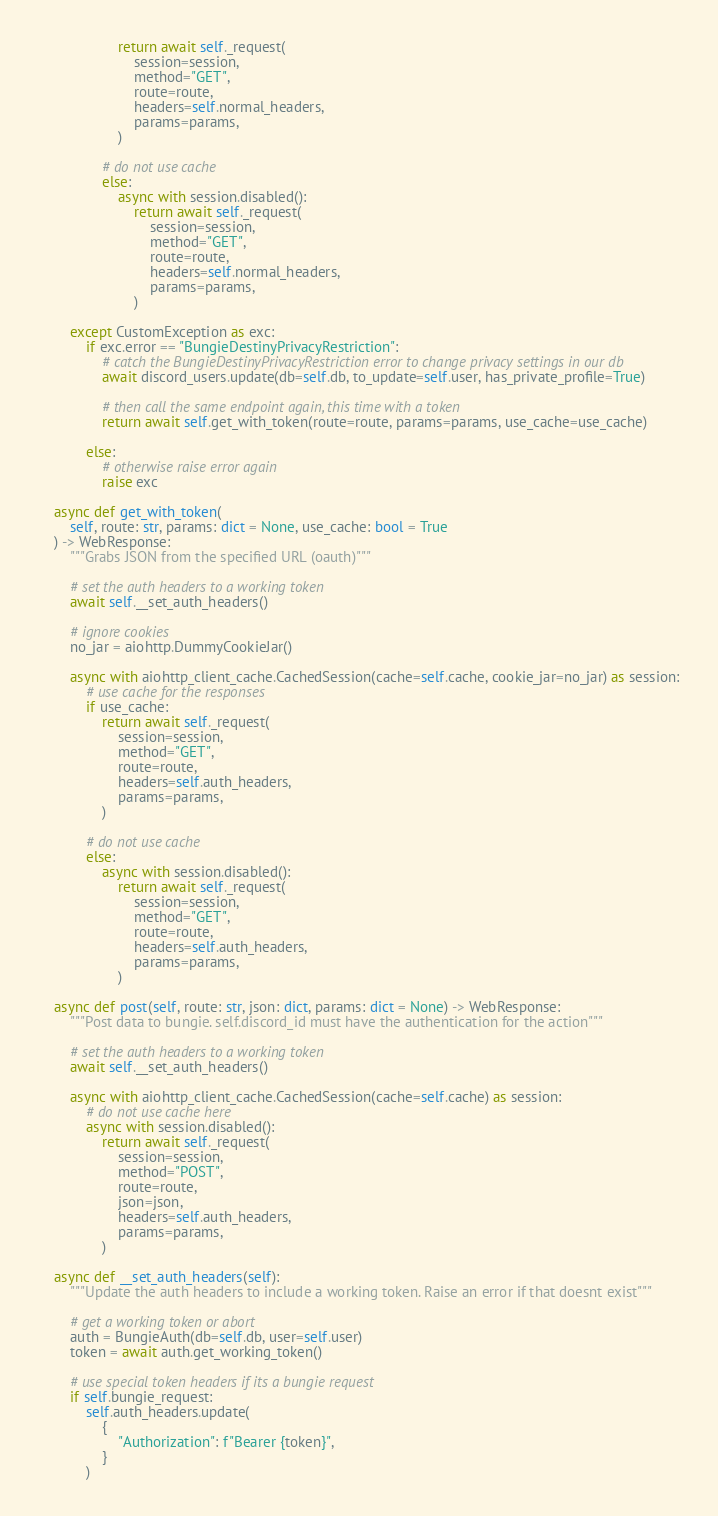<code> <loc_0><loc_0><loc_500><loc_500><_Python_>                    return await self._request(
                        session=session,
                        method="GET",
                        route=route,
                        headers=self.normal_headers,
                        params=params,
                    )

                # do not use cache
                else:
                    async with session.disabled():
                        return await self._request(
                            session=session,
                            method="GET",
                            route=route,
                            headers=self.normal_headers,
                            params=params,
                        )

        except CustomException as exc:
            if exc.error == "BungieDestinyPrivacyRestriction":
                # catch the BungieDestinyPrivacyRestriction error to change privacy settings in our db
                await discord_users.update(db=self.db, to_update=self.user, has_private_profile=True)

                # then call the same endpoint again, this time with a token
                return await self.get_with_token(route=route, params=params, use_cache=use_cache)

            else:
                # otherwise raise error again
                raise exc

    async def get_with_token(
        self, route: str, params: dict = None, use_cache: bool = True
    ) -> WebResponse:
        """Grabs JSON from the specified URL (oauth)"""

        # set the auth headers to a working token
        await self.__set_auth_headers()

        # ignore cookies
        no_jar = aiohttp.DummyCookieJar()

        async with aiohttp_client_cache.CachedSession(cache=self.cache, cookie_jar=no_jar) as session:
            # use cache for the responses
            if use_cache:
                return await self._request(
                    session=session,
                    method="GET",
                    route=route,
                    headers=self.auth_headers,
                    params=params,
                )

            # do not use cache
            else:
                async with session.disabled():
                    return await self._request(
                        session=session,
                        method="GET",
                        route=route,
                        headers=self.auth_headers,
                        params=params,
                    )

    async def post(self, route: str, json: dict, params: dict = None) -> WebResponse:
        """Post data to bungie. self.discord_id must have the authentication for the action"""

        # set the auth headers to a working token
        await self.__set_auth_headers()

        async with aiohttp_client_cache.CachedSession(cache=self.cache) as session:
            # do not use cache here
            async with session.disabled():
                return await self._request(
                    session=session,
                    method="POST",
                    route=route,
                    json=json,
                    headers=self.auth_headers,
                    params=params,
                )

    async def __set_auth_headers(self):
        """Update the auth headers to include a working token. Raise an error if that doesnt exist"""

        # get a working token or abort
        auth = BungieAuth(db=self.db, user=self.user)
        token = await auth.get_working_token()

        # use special token headers if its a bungie request
        if self.bungie_request:
            self.auth_headers.update(
                {
                    "Authorization": f"Bearer {token}",
                }
            )
</code> 